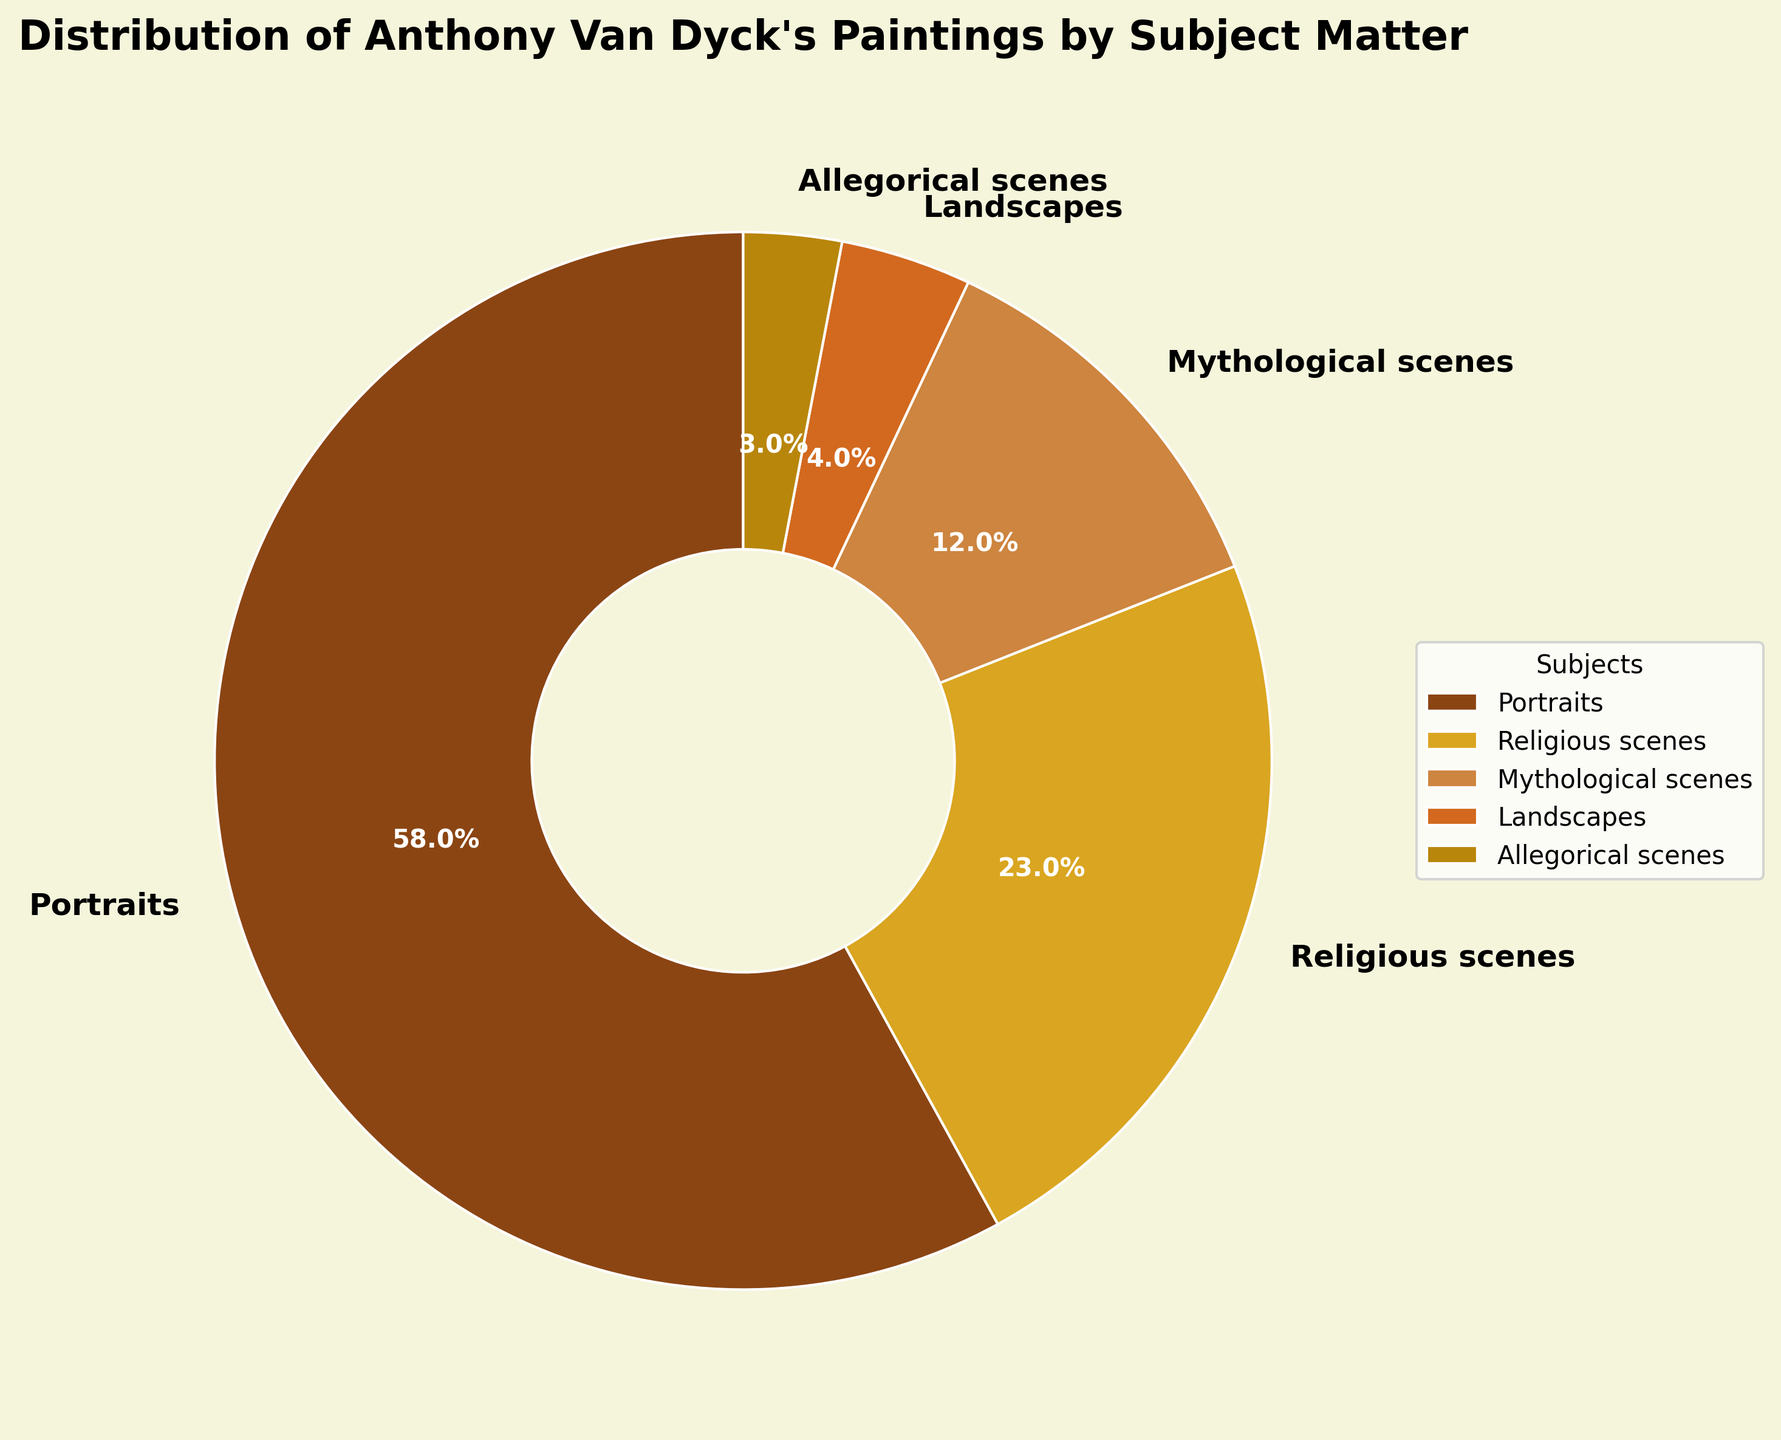What subject matter has the highest percentage of Anthony Van Dyck's paintings? The pie chart shows that the segment labeled "Portraits" has the largest portion of the pie, indicating the highest percentage.
Answer: Portraits What is the combined percentage of Religious scenes and Mythological scenes? Add the percentage of Religious scenes (23%) to the percentage of Mythological scenes (12%) to get the combined percentage: 23% + 12% = 35%.
Answer: 35% What is the difference in percentage between Portraits and Landscapes? Subtract the percentage for Landscapes (4%) from the percentage for Portraits (58%) to find the difference: 58% - 4% = 54%.
Answer: 54% Which subject matter occupies the smallest segment in the pie chart? According to the pie chart, the segment labeled "Allegorical scenes" is the smallest portion.
Answer: Allegorical scenes How many times larger is the percentage of Portraits compared to the percentage of Allegorical scenes? Divide the percentage of Portraits (58%) by the percentage of Allegorical scenes (3%): 58 / 3 ≈ 19.3.
Answer: About 19.3 times What is the total percentage of paintings categorized as either Religious scenes, Mythological scenes, or Allegorical scenes? Add the percentages of Religious scenes (23%), Mythological scenes (12%), and Allegorical scenes (3%): 23% + 12% + 3% = 38%.
Answer: 38% Compare the percentage of Mythological scenes to that of Landscapes. Which is greater and by how much? The percentage of Mythological scenes (12%) is greater than that of Landscapes (4%) by the difference: 12% - 4% = 8%.
Answer: Mythological scenes, 8% Rank the subject matters from the highest to the lowest in terms of their percentage representation in the pie chart. Based on the percentages given: Portraits (58%), Religious scenes (23%), Mythological scenes (12%), Landscapes (4%), Allegorical scenes (3%).
Answer: Portraits > Religious scenes > Mythological scenes > Landscapes > Allegorical scenes What percentage of Van Dyck's paintings are not portraits? Subtract the percentage of Portraits (58%) from 100% to find the percentage that is not portraits: 100% - 58% = 42%.
Answer: 42% If you combined landscapes and allegorical scenes, would their combined percentage be greater than that of mythological scenes? Add the percentage of Landscapes (4%) to that of Allegorical scenes (3%) and compare it to Mythological scenes: 4% + 3% = 7%, which is less than 12%.
Answer: No, 7% is less 